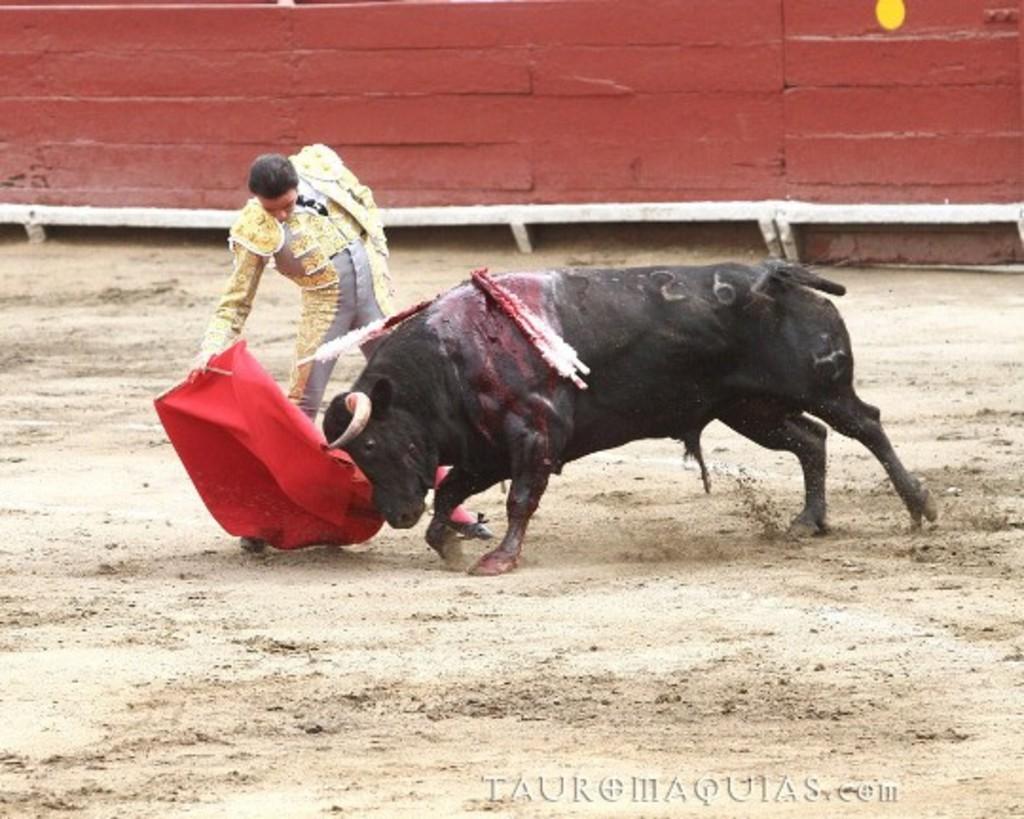Can you describe this image briefly? In the center of the image we can see a bull and a person is standing and holding a cloth and we can see he is in a different costume. And we can see some objects on the bull. At the bottom right side of the image, we can see some text. In the background there is a wall. 